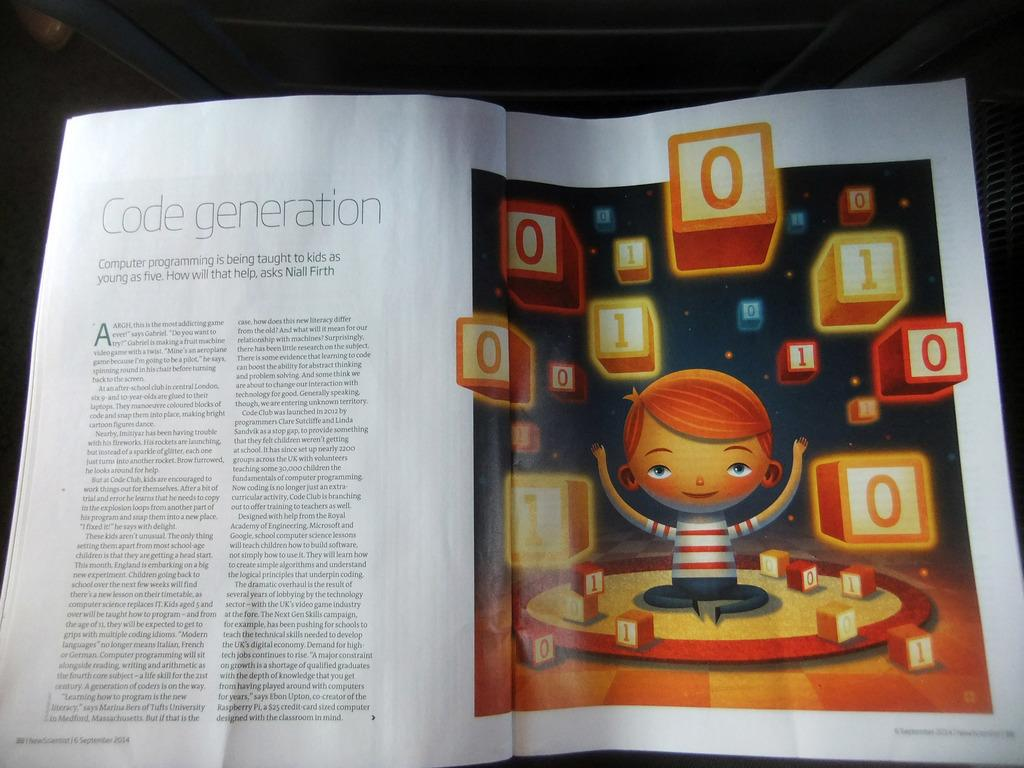<image>
Share a concise interpretation of the image provided. An open magazine with an article titled Code generation that discusses teaching kids to code. 